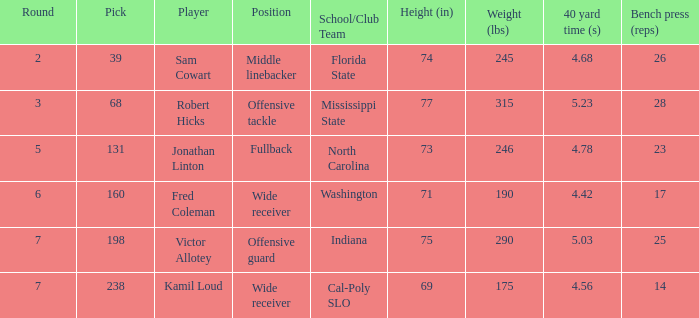Which Round has a School/Club Team of indiana, and a Pick smaller than 198? None. 